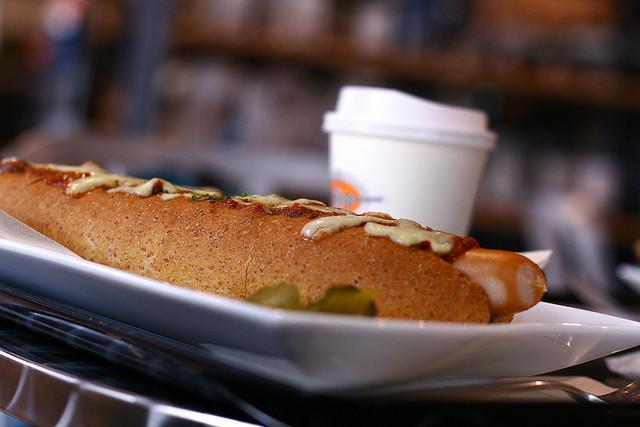How many pickles?
Short answer required. 2. What is in the cup?
Quick response, please. Coffee. Is the plate disposable?
Keep it brief. No. 